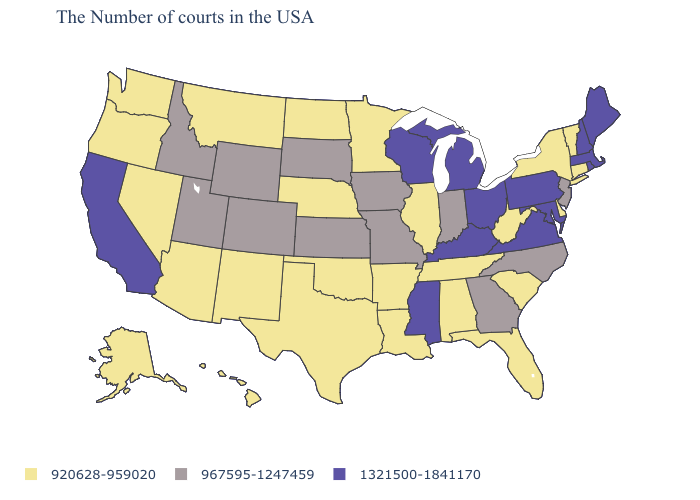Name the states that have a value in the range 1321500-1841170?
Keep it brief. Maine, Massachusetts, Rhode Island, New Hampshire, Maryland, Pennsylvania, Virginia, Ohio, Michigan, Kentucky, Wisconsin, Mississippi, California. Does Arkansas have the lowest value in the South?
Answer briefly. Yes. Does Idaho have a lower value than Kentucky?
Short answer required. Yes. What is the value of Rhode Island?
Answer briefly. 1321500-1841170. Which states hav the highest value in the MidWest?
Be succinct. Ohio, Michigan, Wisconsin. Does Hawaii have the same value as Texas?
Be succinct. Yes. What is the value of Maine?
Write a very short answer. 1321500-1841170. Does Wisconsin have the lowest value in the MidWest?
Write a very short answer. No. Name the states that have a value in the range 920628-959020?
Give a very brief answer. Vermont, Connecticut, New York, Delaware, South Carolina, West Virginia, Florida, Alabama, Tennessee, Illinois, Louisiana, Arkansas, Minnesota, Nebraska, Oklahoma, Texas, North Dakota, New Mexico, Montana, Arizona, Nevada, Washington, Oregon, Alaska, Hawaii. Does New Jersey have the highest value in the Northeast?
Quick response, please. No. Name the states that have a value in the range 967595-1247459?
Quick response, please. New Jersey, North Carolina, Georgia, Indiana, Missouri, Iowa, Kansas, South Dakota, Wyoming, Colorado, Utah, Idaho. Name the states that have a value in the range 1321500-1841170?
Quick response, please. Maine, Massachusetts, Rhode Island, New Hampshire, Maryland, Pennsylvania, Virginia, Ohio, Michigan, Kentucky, Wisconsin, Mississippi, California. What is the value of Ohio?
Give a very brief answer. 1321500-1841170. What is the value of Massachusetts?
Short answer required. 1321500-1841170. Does Michigan have the same value as Rhode Island?
Quick response, please. Yes. 